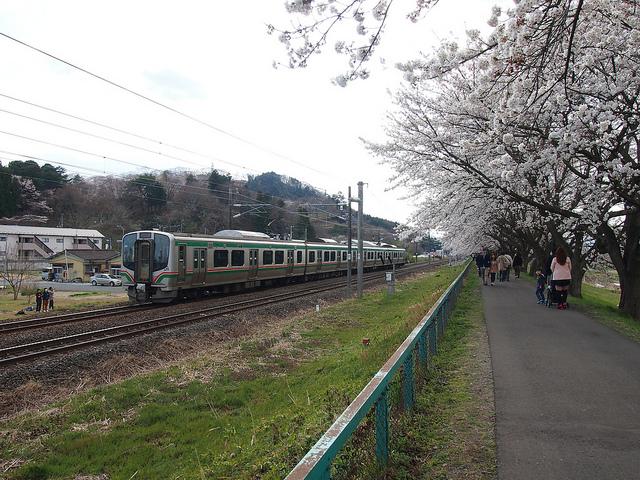What is the train riding on?
Keep it brief. Tracks. What type of trees are in bloom?
Concise answer only. Cherry. What material is the fence made of?
Concise answer only. Metal. 